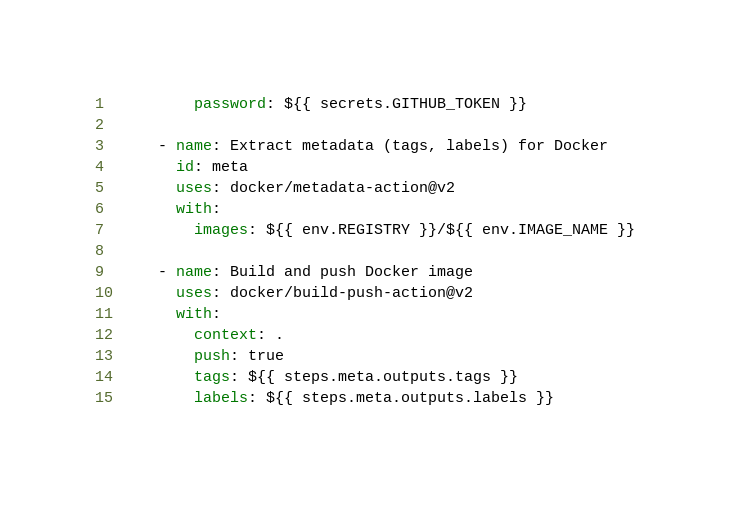<code> <loc_0><loc_0><loc_500><loc_500><_YAML_>          password: ${{ secrets.GITHUB_TOKEN }}

      - name: Extract metadata (tags, labels) for Docker
        id: meta
        uses: docker/metadata-action@v2
        with:
          images: ${{ env.REGISTRY }}/${{ env.IMAGE_NAME }}

      - name: Build and push Docker image
        uses: docker/build-push-action@v2
        with:
          context: .
          push: true
          tags: ${{ steps.meta.outputs.tags }}
          labels: ${{ steps.meta.outputs.labels }}</code> 